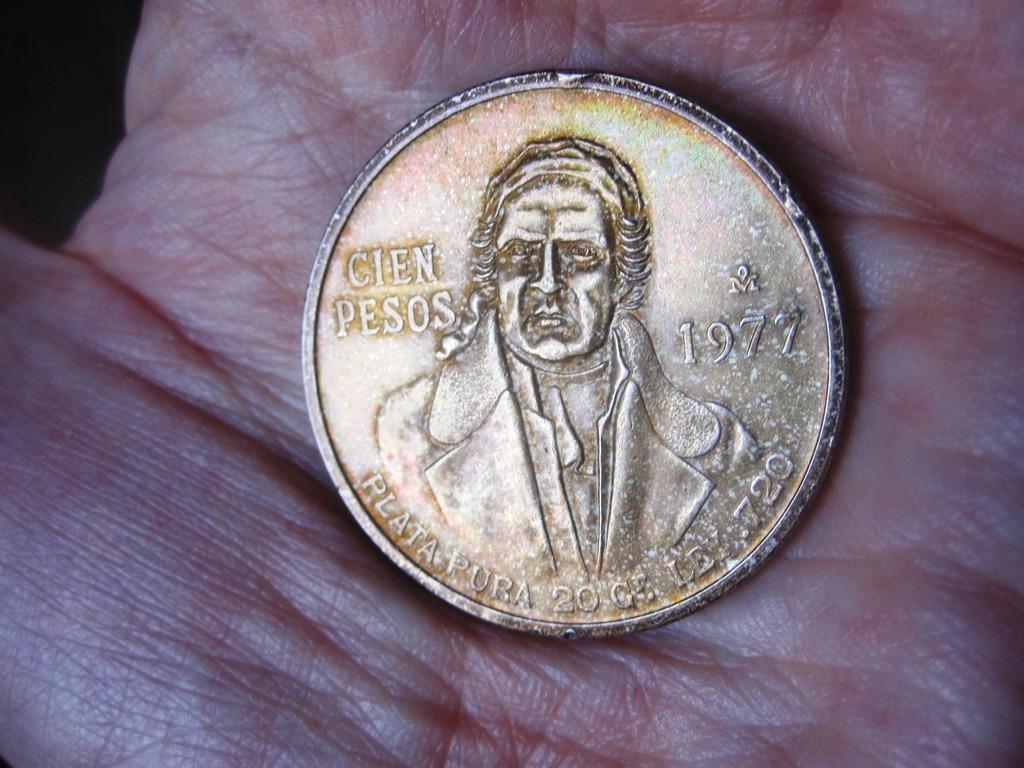<image>
Write a terse but informative summary of the picture. a coin for Cien Pesos minted in 1977 held in a hand 